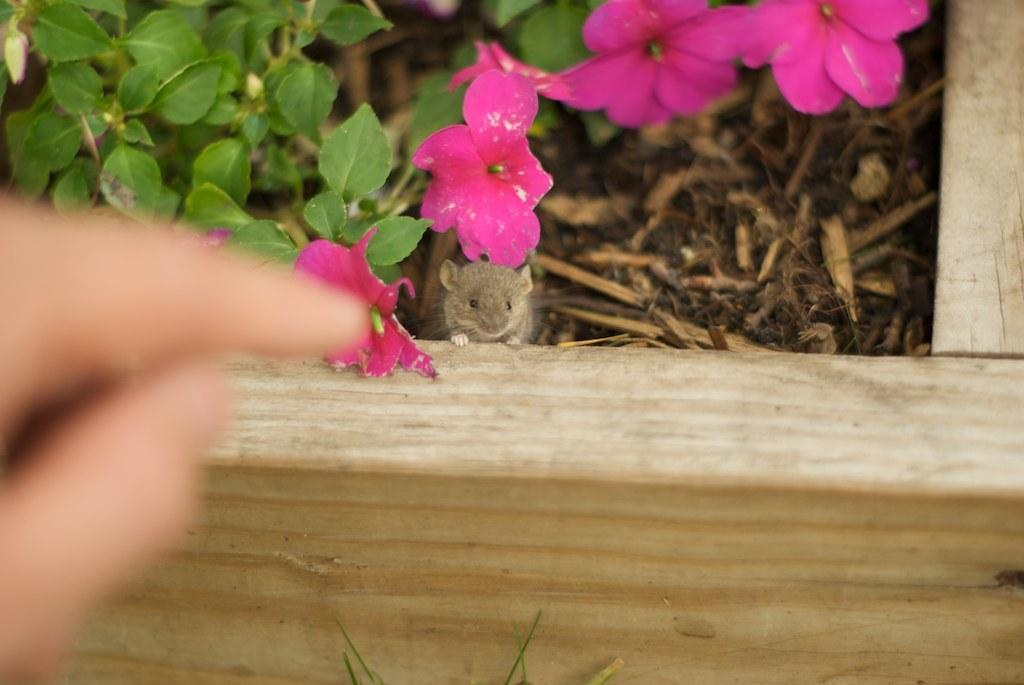What part of a person's body is visible in the image? There are a person's fingers visible in the image. What type of object can be seen in the background of the image? There is a wooden object in the background of the image. What animals are present in the background of the image? There are mice in the background of the image. What type of vegetation is visible in the background of the image? There are plants with flowers in the background of the image. What other objects can be seen in the background of the image? There are wooden sticks in the background of the image. What is the person's opinion about the pleasure of the eye in the image? There is no indication of the person's opinion or any reference to pleasure of the eye in the image. 